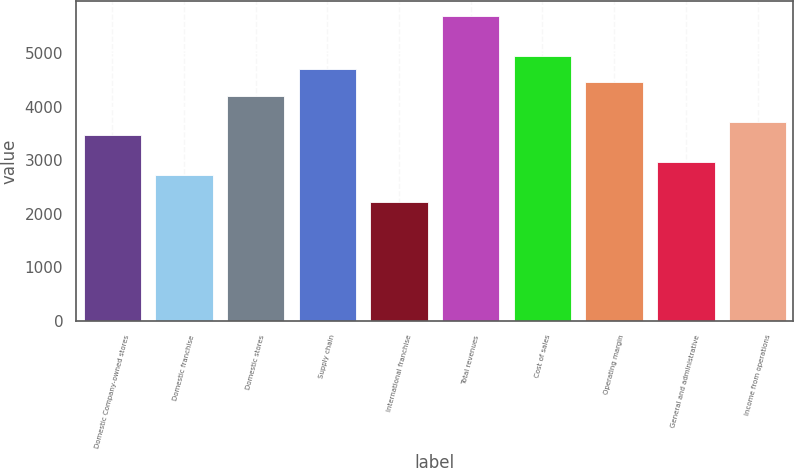Convert chart to OTSL. <chart><loc_0><loc_0><loc_500><loc_500><bar_chart><fcel>Domestic Company-owned stores<fcel>Domestic franchise<fcel>Domestic stores<fcel>Supply chain<fcel>International franchise<fcel>Total revenues<fcel>Cost of sales<fcel>Operating margin<fcel>General and administrative<fcel>Income from operations<nl><fcel>3461.36<fcel>2719.79<fcel>4202.93<fcel>4697.31<fcel>2225.41<fcel>5686.07<fcel>4944.5<fcel>4450.12<fcel>2966.98<fcel>3708.55<nl></chart> 